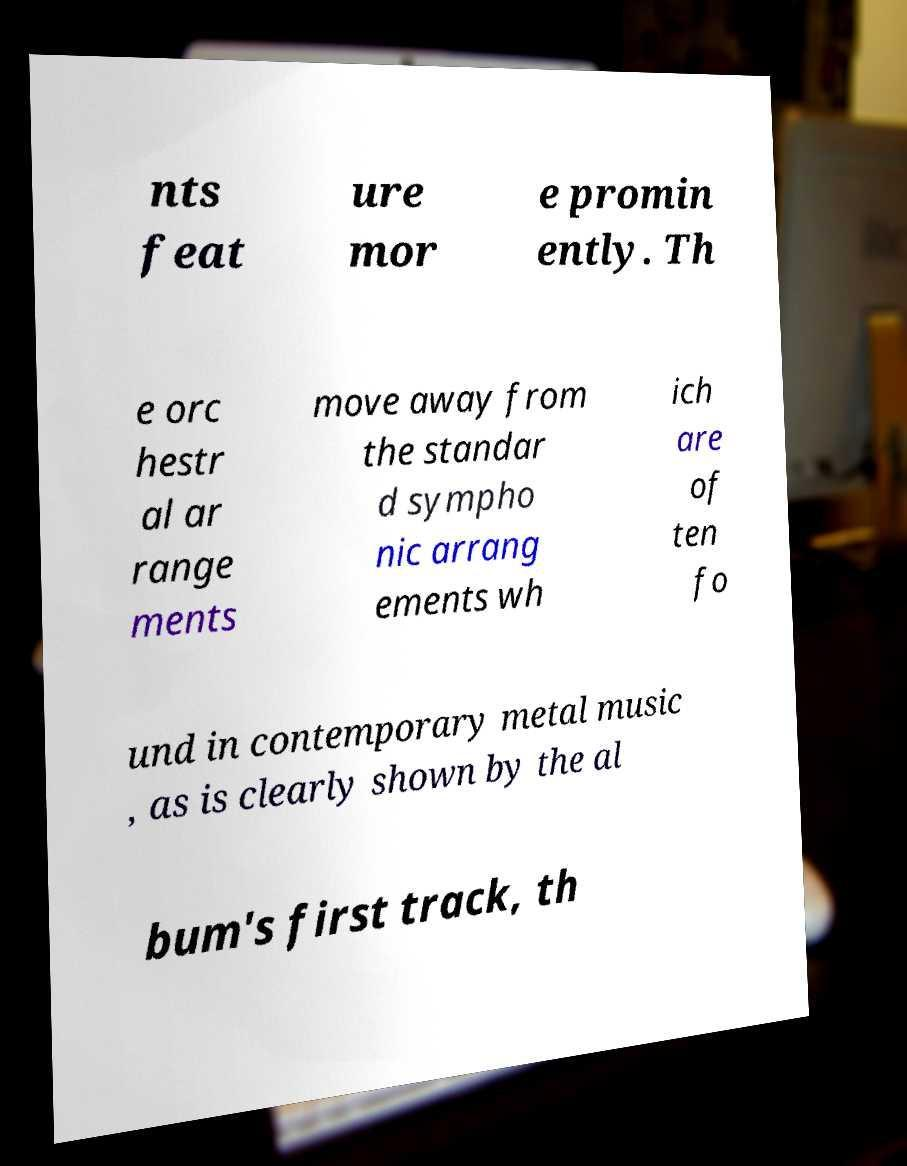I need the written content from this picture converted into text. Can you do that? nts feat ure mor e promin ently. Th e orc hestr al ar range ments move away from the standar d sympho nic arrang ements wh ich are of ten fo und in contemporary metal music , as is clearly shown by the al bum's first track, th 